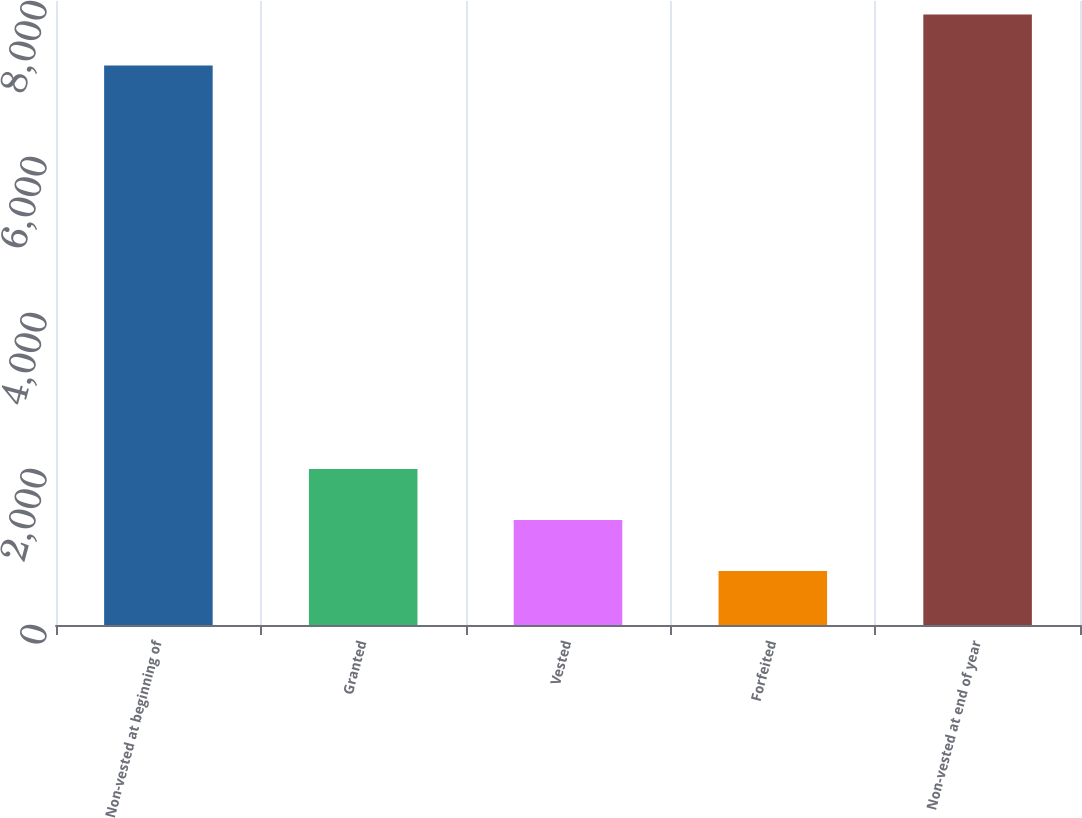<chart> <loc_0><loc_0><loc_500><loc_500><bar_chart><fcel>Non-vested at beginning of<fcel>Granted<fcel>Vested<fcel>Forfeited<fcel>Non-vested at end of year<nl><fcel>7172<fcel>2000.8<fcel>1346.9<fcel>693<fcel>7825.9<nl></chart> 